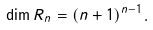Convert formula to latex. <formula><loc_0><loc_0><loc_500><loc_500>\dim R _ { n } = ( n + 1 ) ^ { n - 1 } .</formula> 